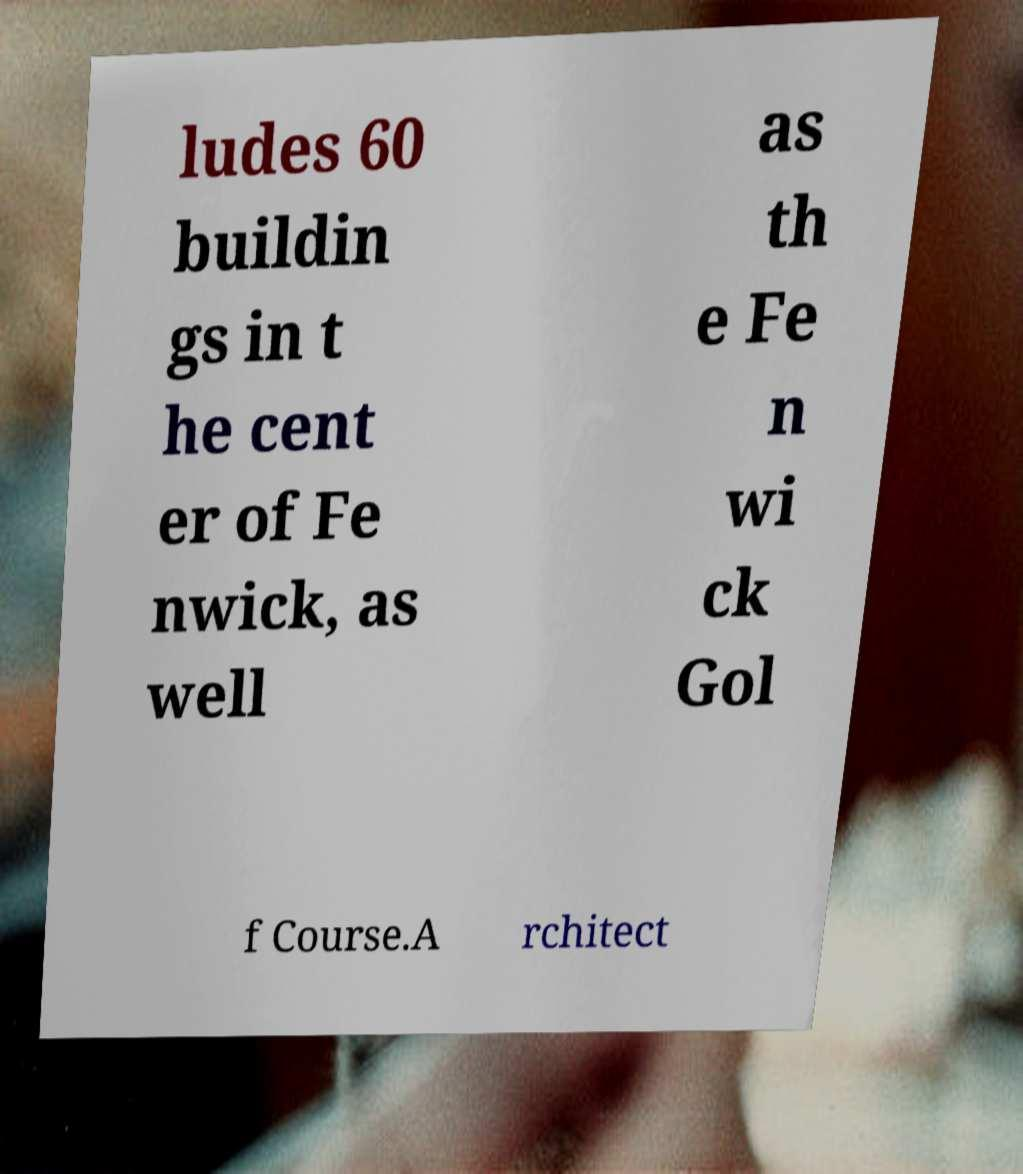Can you read and provide the text displayed in the image?This photo seems to have some interesting text. Can you extract and type it out for me? ludes 60 buildin gs in t he cent er of Fe nwick, as well as th e Fe n wi ck Gol f Course.A rchitect 